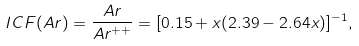<formula> <loc_0><loc_0><loc_500><loc_500>I C F ( A r ) = \frac { A r } { A r ^ { + + } } = [ 0 . 1 5 + x ( 2 . 3 9 - 2 . 6 4 x ) ] ^ { - 1 } ,</formula> 